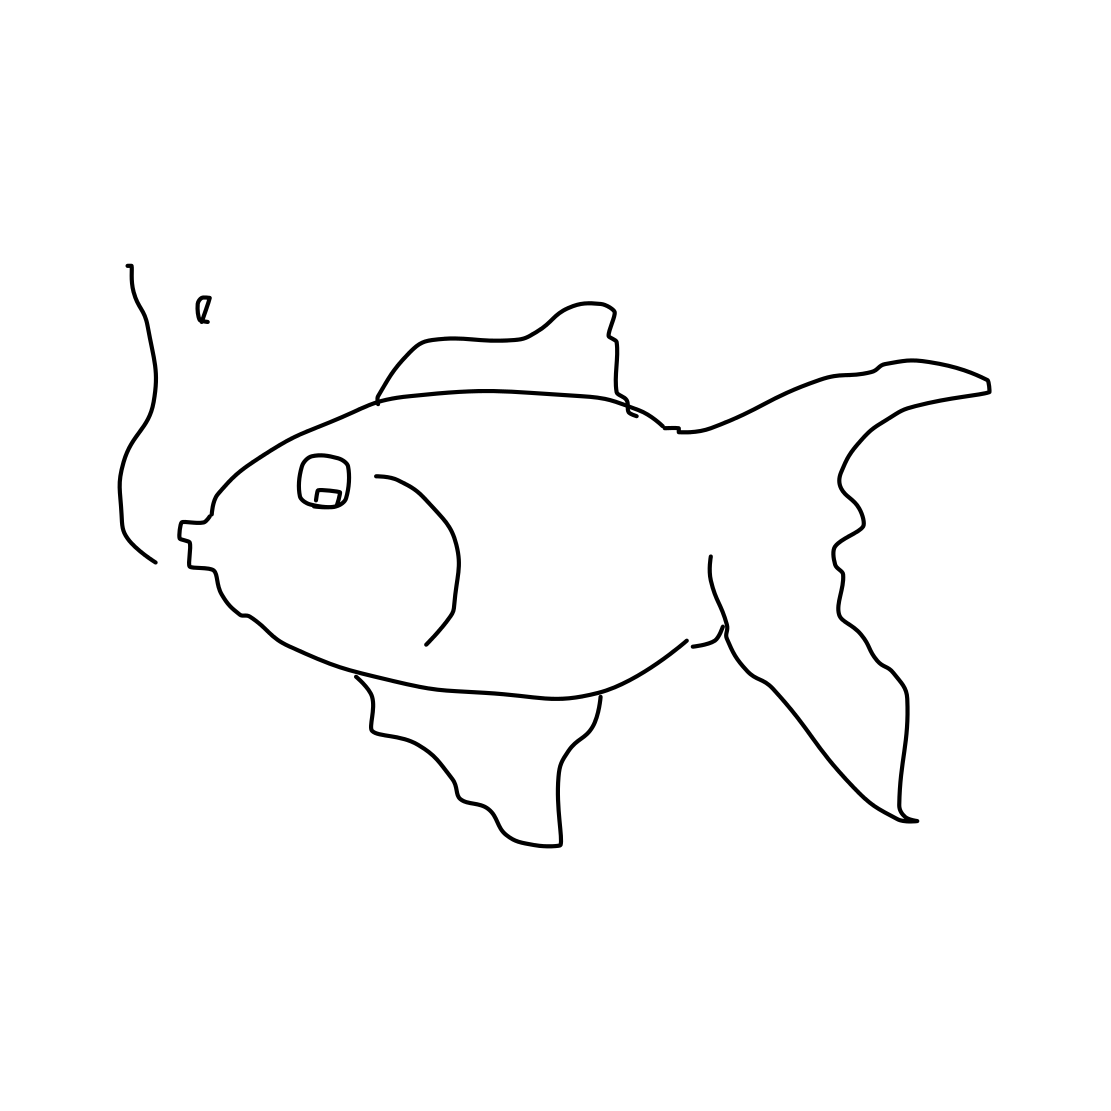Is there a sketchy wheel in the picture? After reviewing the image, it's clear that there is no wheel present. Instead, what we see is a simple line drawing of a fish that appears to be fashioned out of disconnected, sketch-like contours. Its charm lies in its minimalistic approach, capturing the essence of the fish with just a few lines. 